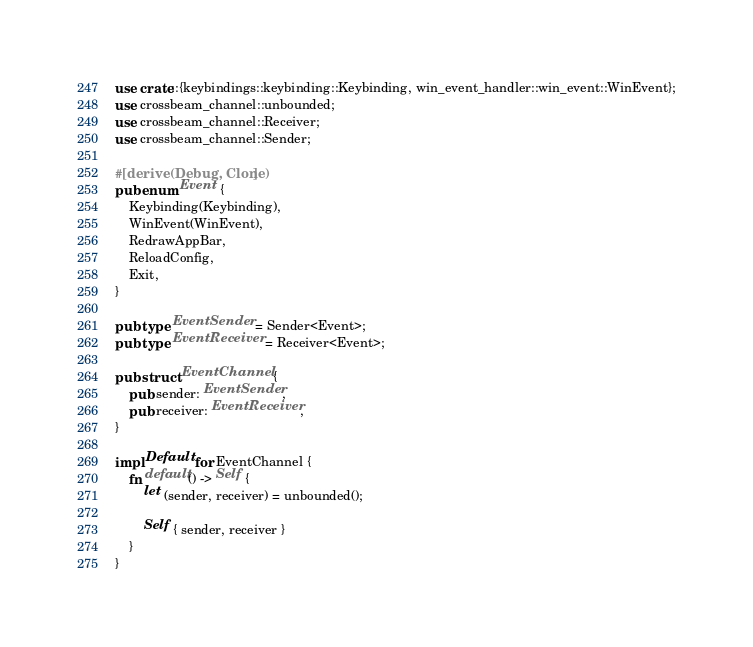<code> <loc_0><loc_0><loc_500><loc_500><_Rust_>use crate::{keybindings::keybinding::Keybinding, win_event_handler::win_event::WinEvent};
use crossbeam_channel::unbounded;
use crossbeam_channel::Receiver;
use crossbeam_channel::Sender;

#[derive(Debug, Clone)]
pub enum Event {
    Keybinding(Keybinding),
    WinEvent(WinEvent),
    RedrawAppBar,
    ReloadConfig,
    Exit,
}

pub type EventSender = Sender<Event>;
pub type EventReceiver = Receiver<Event>;

pub struct EventChannel {
    pub sender: EventSender,
    pub receiver: EventReceiver,
}

impl Default for EventChannel {
    fn default() -> Self {
        let (sender, receiver) = unbounded();

        Self { sender, receiver }
    }
}
</code> 